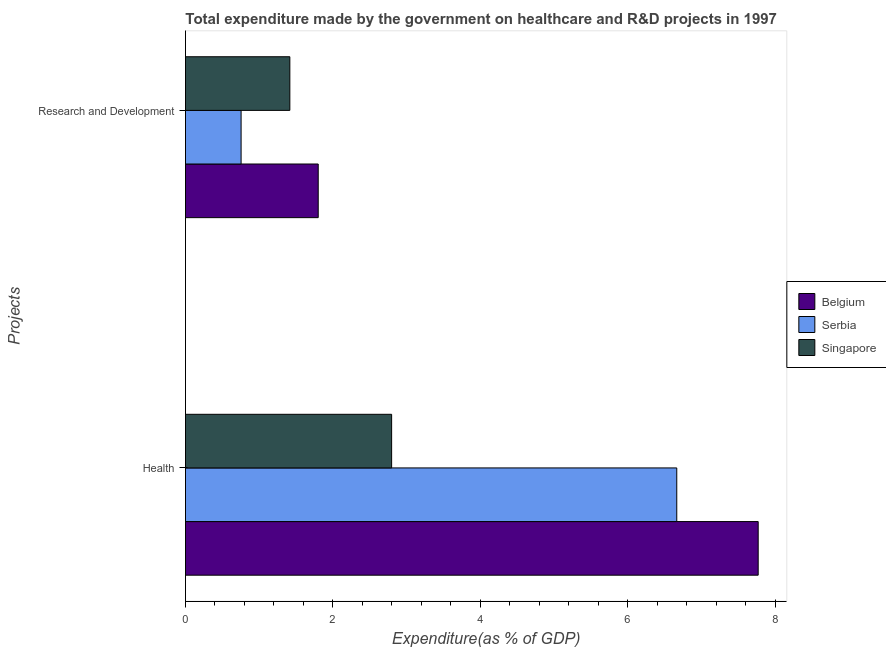How many different coloured bars are there?
Ensure brevity in your answer.  3. How many groups of bars are there?
Keep it short and to the point. 2. What is the label of the 1st group of bars from the top?
Ensure brevity in your answer.  Research and Development. What is the expenditure in healthcare in Belgium?
Offer a terse response. 7.77. Across all countries, what is the maximum expenditure in healthcare?
Give a very brief answer. 7.77. Across all countries, what is the minimum expenditure in healthcare?
Provide a succinct answer. 2.8. In which country was the expenditure in healthcare minimum?
Provide a succinct answer. Singapore. What is the total expenditure in r&d in the graph?
Keep it short and to the point. 3.97. What is the difference between the expenditure in r&d in Belgium and that in Serbia?
Offer a very short reply. 1.05. What is the difference between the expenditure in healthcare in Singapore and the expenditure in r&d in Belgium?
Provide a succinct answer. 1. What is the average expenditure in r&d per country?
Give a very brief answer. 1.32. What is the difference between the expenditure in healthcare and expenditure in r&d in Belgium?
Provide a short and direct response. 5.97. In how many countries, is the expenditure in r&d greater than 3.2 %?
Make the answer very short. 0. What is the ratio of the expenditure in healthcare in Serbia to that in Belgium?
Make the answer very short. 0.86. In how many countries, is the expenditure in healthcare greater than the average expenditure in healthcare taken over all countries?
Your answer should be very brief. 2. What does the 1st bar from the top in Health represents?
Keep it short and to the point. Singapore. What does the 2nd bar from the bottom in Research and Development represents?
Your answer should be compact. Serbia. What is the difference between two consecutive major ticks on the X-axis?
Offer a terse response. 2. Does the graph contain grids?
Give a very brief answer. No. How are the legend labels stacked?
Give a very brief answer. Vertical. What is the title of the graph?
Your answer should be very brief. Total expenditure made by the government on healthcare and R&D projects in 1997. What is the label or title of the X-axis?
Your answer should be compact. Expenditure(as % of GDP). What is the label or title of the Y-axis?
Give a very brief answer. Projects. What is the Expenditure(as % of GDP) in Belgium in Health?
Your response must be concise. 7.77. What is the Expenditure(as % of GDP) of Serbia in Health?
Provide a succinct answer. 6.66. What is the Expenditure(as % of GDP) of Singapore in Health?
Your response must be concise. 2.8. What is the Expenditure(as % of GDP) in Belgium in Research and Development?
Your answer should be very brief. 1.8. What is the Expenditure(as % of GDP) of Serbia in Research and Development?
Your response must be concise. 0.75. What is the Expenditure(as % of GDP) of Singapore in Research and Development?
Provide a short and direct response. 1.42. Across all Projects, what is the maximum Expenditure(as % of GDP) of Belgium?
Your response must be concise. 7.77. Across all Projects, what is the maximum Expenditure(as % of GDP) in Serbia?
Offer a very short reply. 6.66. Across all Projects, what is the maximum Expenditure(as % of GDP) of Singapore?
Make the answer very short. 2.8. Across all Projects, what is the minimum Expenditure(as % of GDP) in Belgium?
Make the answer very short. 1.8. Across all Projects, what is the minimum Expenditure(as % of GDP) in Serbia?
Ensure brevity in your answer.  0.75. Across all Projects, what is the minimum Expenditure(as % of GDP) in Singapore?
Your response must be concise. 1.42. What is the total Expenditure(as % of GDP) in Belgium in the graph?
Make the answer very short. 9.57. What is the total Expenditure(as % of GDP) of Serbia in the graph?
Offer a very short reply. 7.42. What is the total Expenditure(as % of GDP) of Singapore in the graph?
Ensure brevity in your answer.  4.21. What is the difference between the Expenditure(as % of GDP) of Belgium in Health and that in Research and Development?
Your answer should be compact. 5.97. What is the difference between the Expenditure(as % of GDP) in Serbia in Health and that in Research and Development?
Your answer should be compact. 5.91. What is the difference between the Expenditure(as % of GDP) in Singapore in Health and that in Research and Development?
Your answer should be compact. 1.38. What is the difference between the Expenditure(as % of GDP) of Belgium in Health and the Expenditure(as % of GDP) of Serbia in Research and Development?
Offer a terse response. 7.01. What is the difference between the Expenditure(as % of GDP) of Belgium in Health and the Expenditure(as % of GDP) of Singapore in Research and Development?
Your answer should be very brief. 6.35. What is the difference between the Expenditure(as % of GDP) in Serbia in Health and the Expenditure(as % of GDP) in Singapore in Research and Development?
Your response must be concise. 5.25. What is the average Expenditure(as % of GDP) in Belgium per Projects?
Your answer should be very brief. 4.78. What is the average Expenditure(as % of GDP) in Serbia per Projects?
Offer a terse response. 3.71. What is the average Expenditure(as % of GDP) of Singapore per Projects?
Ensure brevity in your answer.  2.11. What is the difference between the Expenditure(as % of GDP) in Belgium and Expenditure(as % of GDP) in Serbia in Health?
Ensure brevity in your answer.  1.1. What is the difference between the Expenditure(as % of GDP) of Belgium and Expenditure(as % of GDP) of Singapore in Health?
Give a very brief answer. 4.97. What is the difference between the Expenditure(as % of GDP) of Serbia and Expenditure(as % of GDP) of Singapore in Health?
Keep it short and to the point. 3.87. What is the difference between the Expenditure(as % of GDP) in Belgium and Expenditure(as % of GDP) in Serbia in Research and Development?
Keep it short and to the point. 1.05. What is the difference between the Expenditure(as % of GDP) of Belgium and Expenditure(as % of GDP) of Singapore in Research and Development?
Provide a short and direct response. 0.38. What is the difference between the Expenditure(as % of GDP) of Serbia and Expenditure(as % of GDP) of Singapore in Research and Development?
Offer a terse response. -0.66. What is the ratio of the Expenditure(as % of GDP) in Belgium in Health to that in Research and Development?
Keep it short and to the point. 4.31. What is the ratio of the Expenditure(as % of GDP) in Serbia in Health to that in Research and Development?
Keep it short and to the point. 8.83. What is the ratio of the Expenditure(as % of GDP) of Singapore in Health to that in Research and Development?
Offer a very short reply. 1.98. What is the difference between the highest and the second highest Expenditure(as % of GDP) of Belgium?
Ensure brevity in your answer.  5.97. What is the difference between the highest and the second highest Expenditure(as % of GDP) of Serbia?
Offer a very short reply. 5.91. What is the difference between the highest and the second highest Expenditure(as % of GDP) in Singapore?
Keep it short and to the point. 1.38. What is the difference between the highest and the lowest Expenditure(as % of GDP) of Belgium?
Keep it short and to the point. 5.97. What is the difference between the highest and the lowest Expenditure(as % of GDP) in Serbia?
Offer a terse response. 5.91. What is the difference between the highest and the lowest Expenditure(as % of GDP) in Singapore?
Provide a short and direct response. 1.38. 